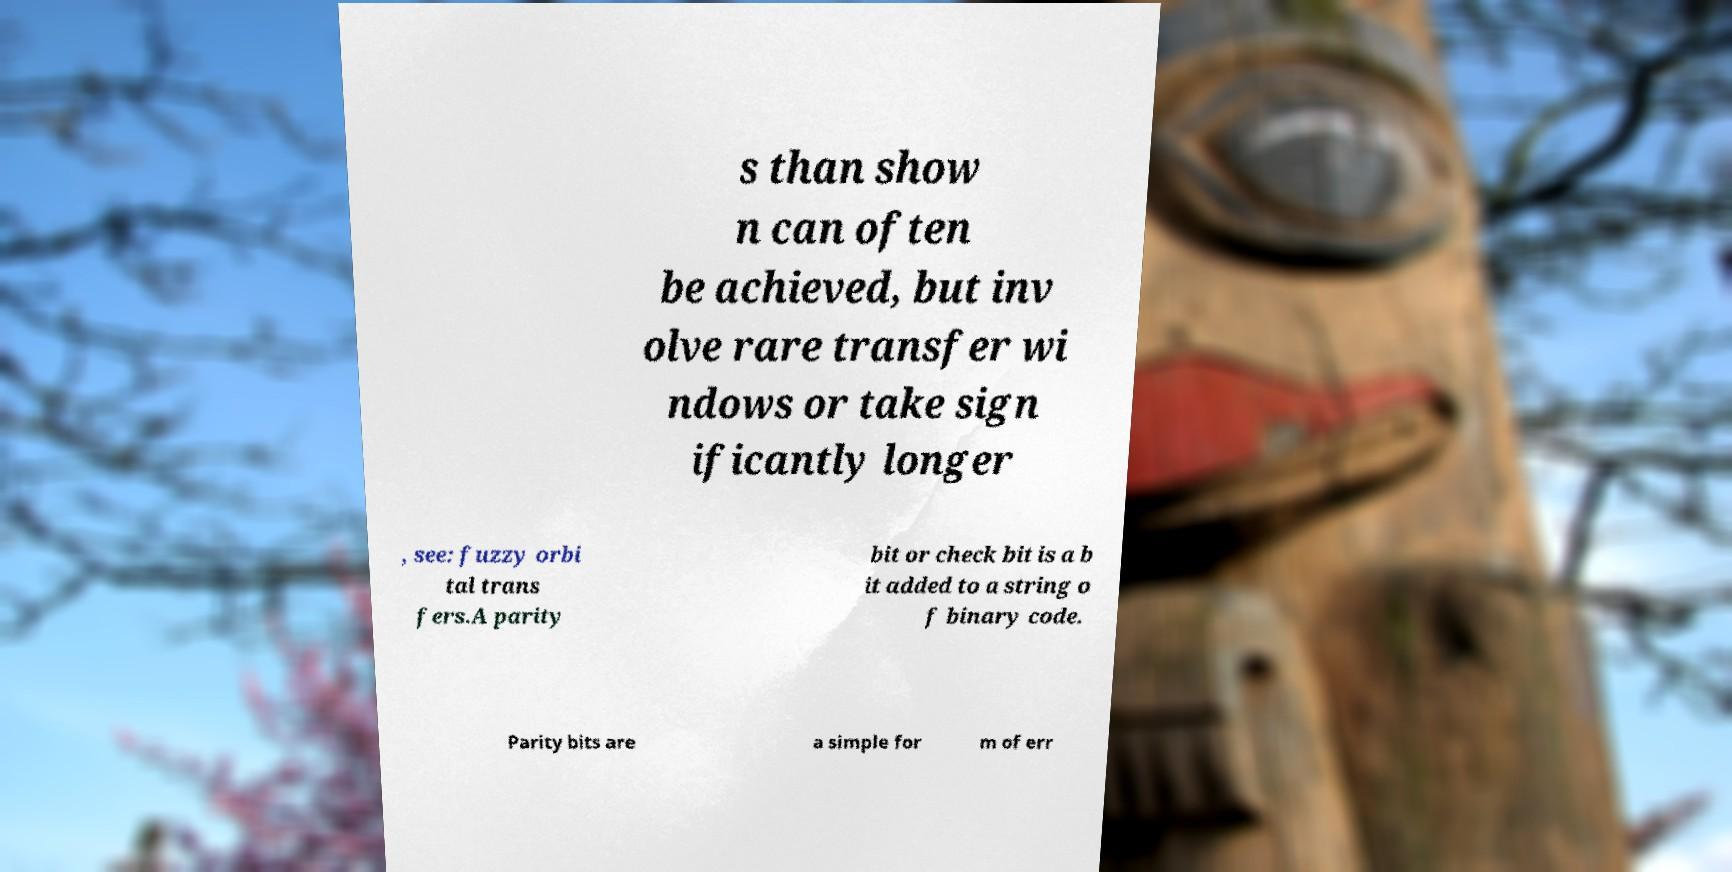What messages or text are displayed in this image? I need them in a readable, typed format. s than show n can often be achieved, but inv olve rare transfer wi ndows or take sign ificantly longer , see: fuzzy orbi tal trans fers.A parity bit or check bit is a b it added to a string o f binary code. Parity bits are a simple for m of err 